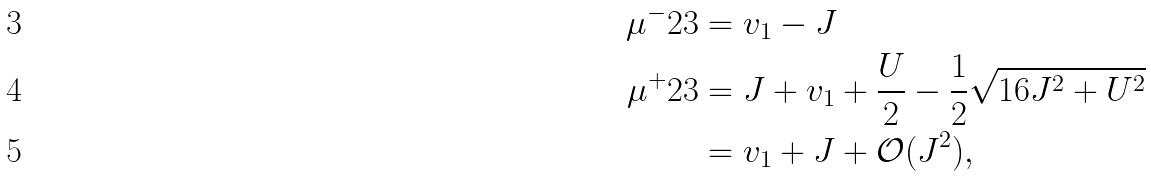<formula> <loc_0><loc_0><loc_500><loc_500>\mu ^ { - } _ { } { 2 } 3 & = v _ { 1 } - J \\ \mu ^ { + } _ { } { 2 } 3 & = J + v _ { 1 } + \frac { U } { 2 } - \frac { 1 } { 2 } \sqrt { 1 6 J ^ { 2 } + U ^ { 2 } } \\ & = v _ { 1 } + J + \mathcal { O } ( J ^ { 2 } ) ,</formula> 